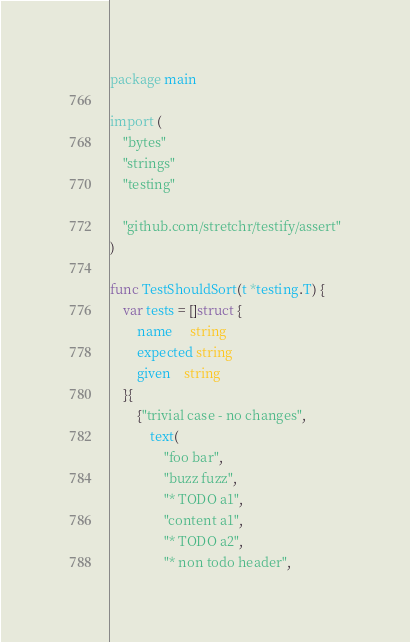Convert code to text. <code><loc_0><loc_0><loc_500><loc_500><_Go_>package main

import (
	"bytes"
	"strings"
	"testing"

	"github.com/stretchr/testify/assert"
)

func TestShouldSort(t *testing.T) {
	var tests = []struct {
		name     string
		expected string
		given    string
	}{
		{"trivial case - no changes",
			text(
				"foo bar",
				"buzz fuzz",
				"* TODO a1",
				"content a1",
				"* TODO a2",
				"* non todo header",</code> 